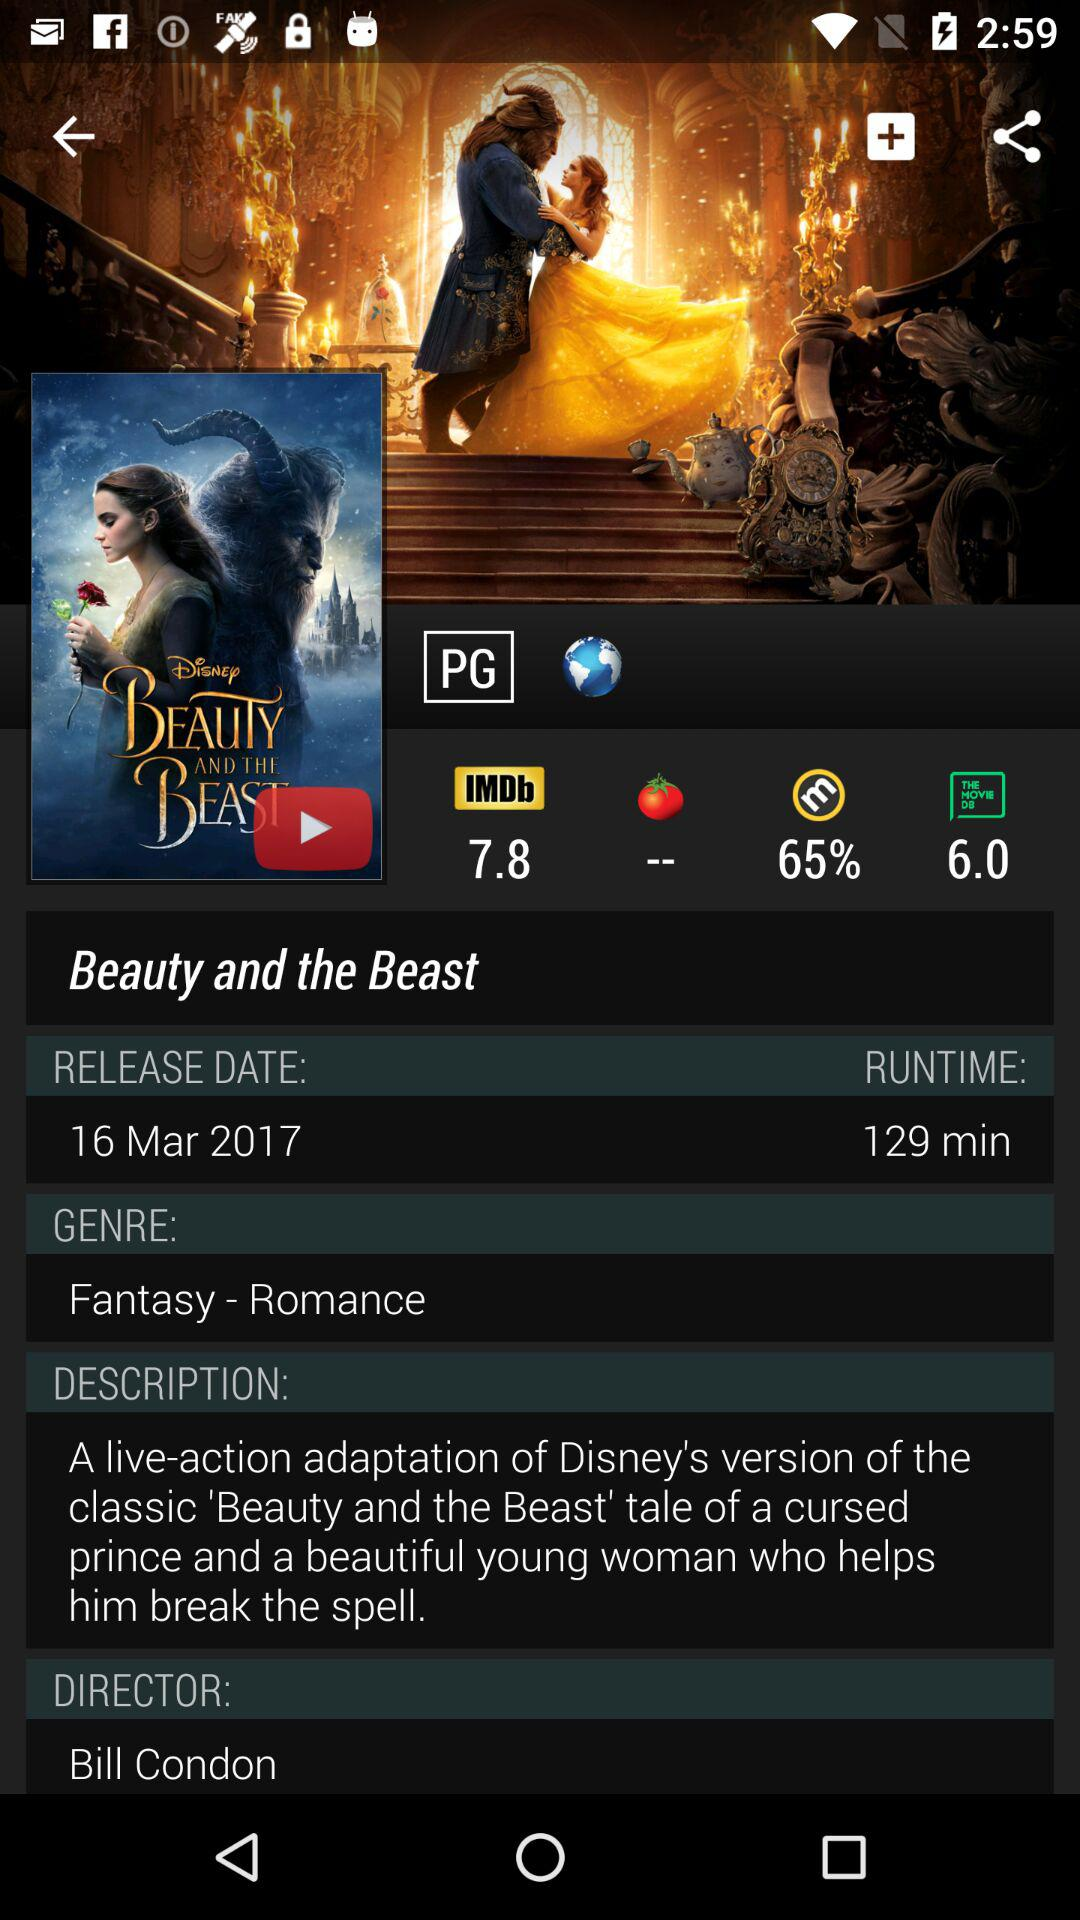What is the IMDb rating of "Beauty and the Beast"? The IMDb rating is 7.8. 